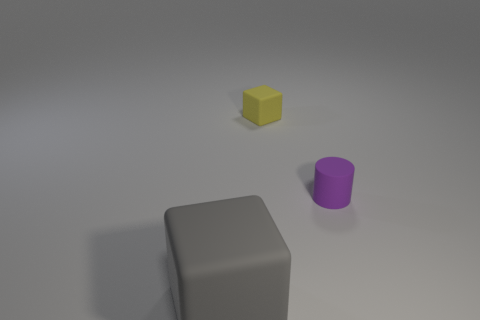Add 1 red rubber cylinders. How many objects exist? 4 Subtract all cylinders. How many objects are left? 2 Add 1 big blocks. How many big blocks are left? 2 Add 3 tiny green rubber cubes. How many tiny green rubber cubes exist? 3 Subtract 0 red cylinders. How many objects are left? 3 Subtract all gray matte things. Subtract all tiny purple objects. How many objects are left? 1 